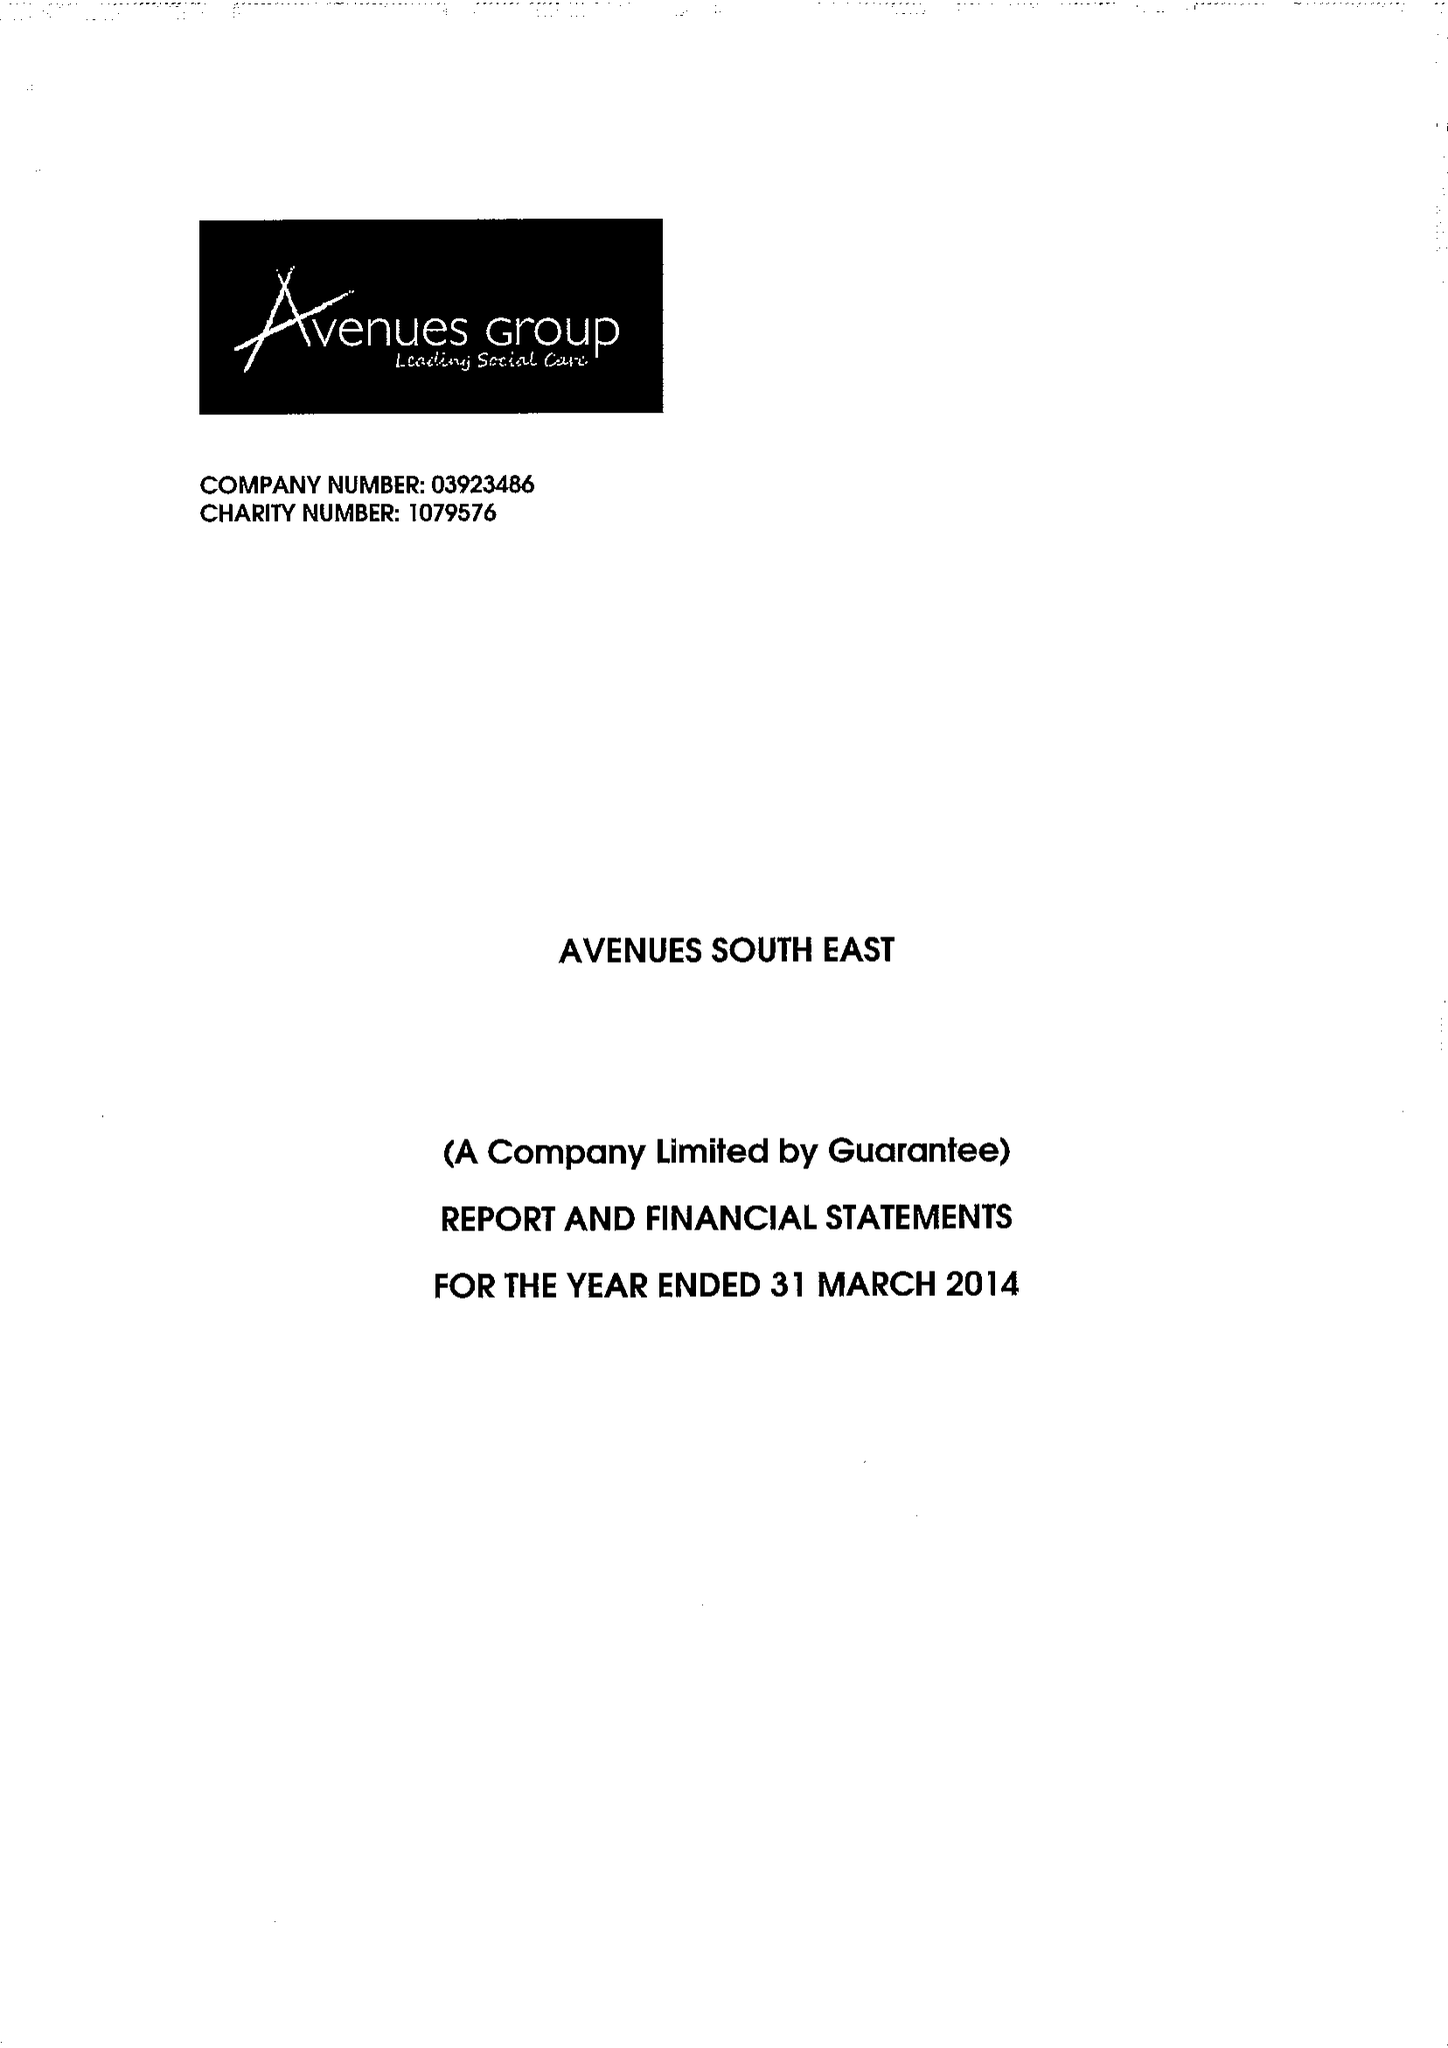What is the value for the report_date?
Answer the question using a single word or phrase. 2014-03-31 